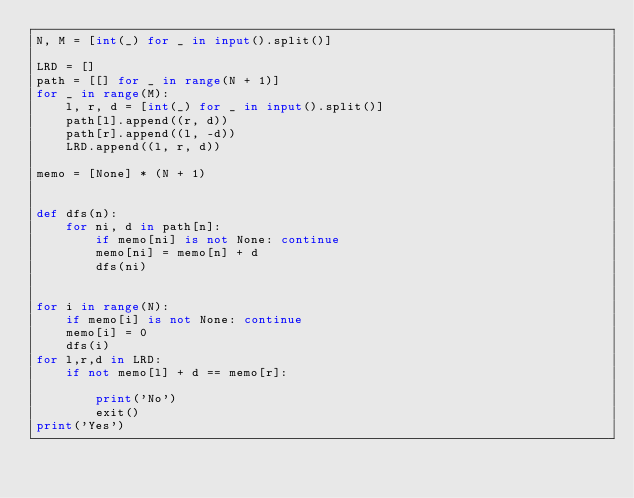Convert code to text. <code><loc_0><loc_0><loc_500><loc_500><_Python_>N, M = [int(_) for _ in input().split()]

LRD = []
path = [[] for _ in range(N + 1)]
for _ in range(M):
    l, r, d = [int(_) for _ in input().split()]
    path[l].append((r, d))
    path[r].append((l, -d))
    LRD.append((l, r, d))

memo = [None] * (N + 1)


def dfs(n):
    for ni, d in path[n]:
        if memo[ni] is not None: continue
        memo[ni] = memo[n] + d
        dfs(ni)


for i in range(N):
    if memo[i] is not None: continue
    memo[i] = 0
    dfs(i)
for l,r,d in LRD:
    if not memo[l] + d == memo[r]:

        print('No')
        exit()
print('Yes')
</code> 